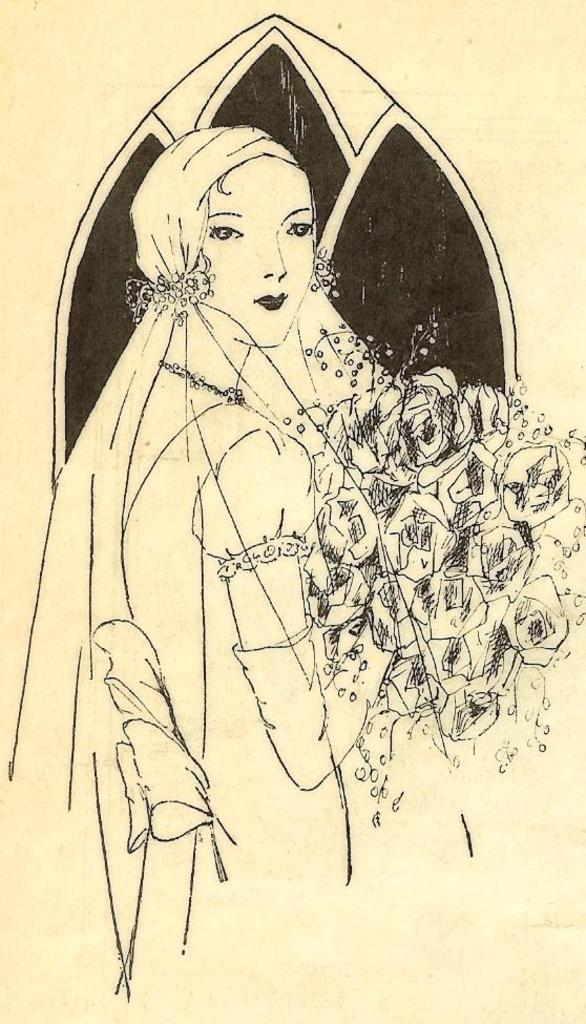What is depicted in the picture? There is a drawing of a woman in the picture. What is the woman holding in her hand? The woman is holding flowers in her hand. What type of support can be seen in the picture? There is no support visible in the picture; it features a drawing of a woman holding flowers. Is there a locket visible in the picture? There is no locket present in the picture; it only features a drawing of a woman holding flowers. 